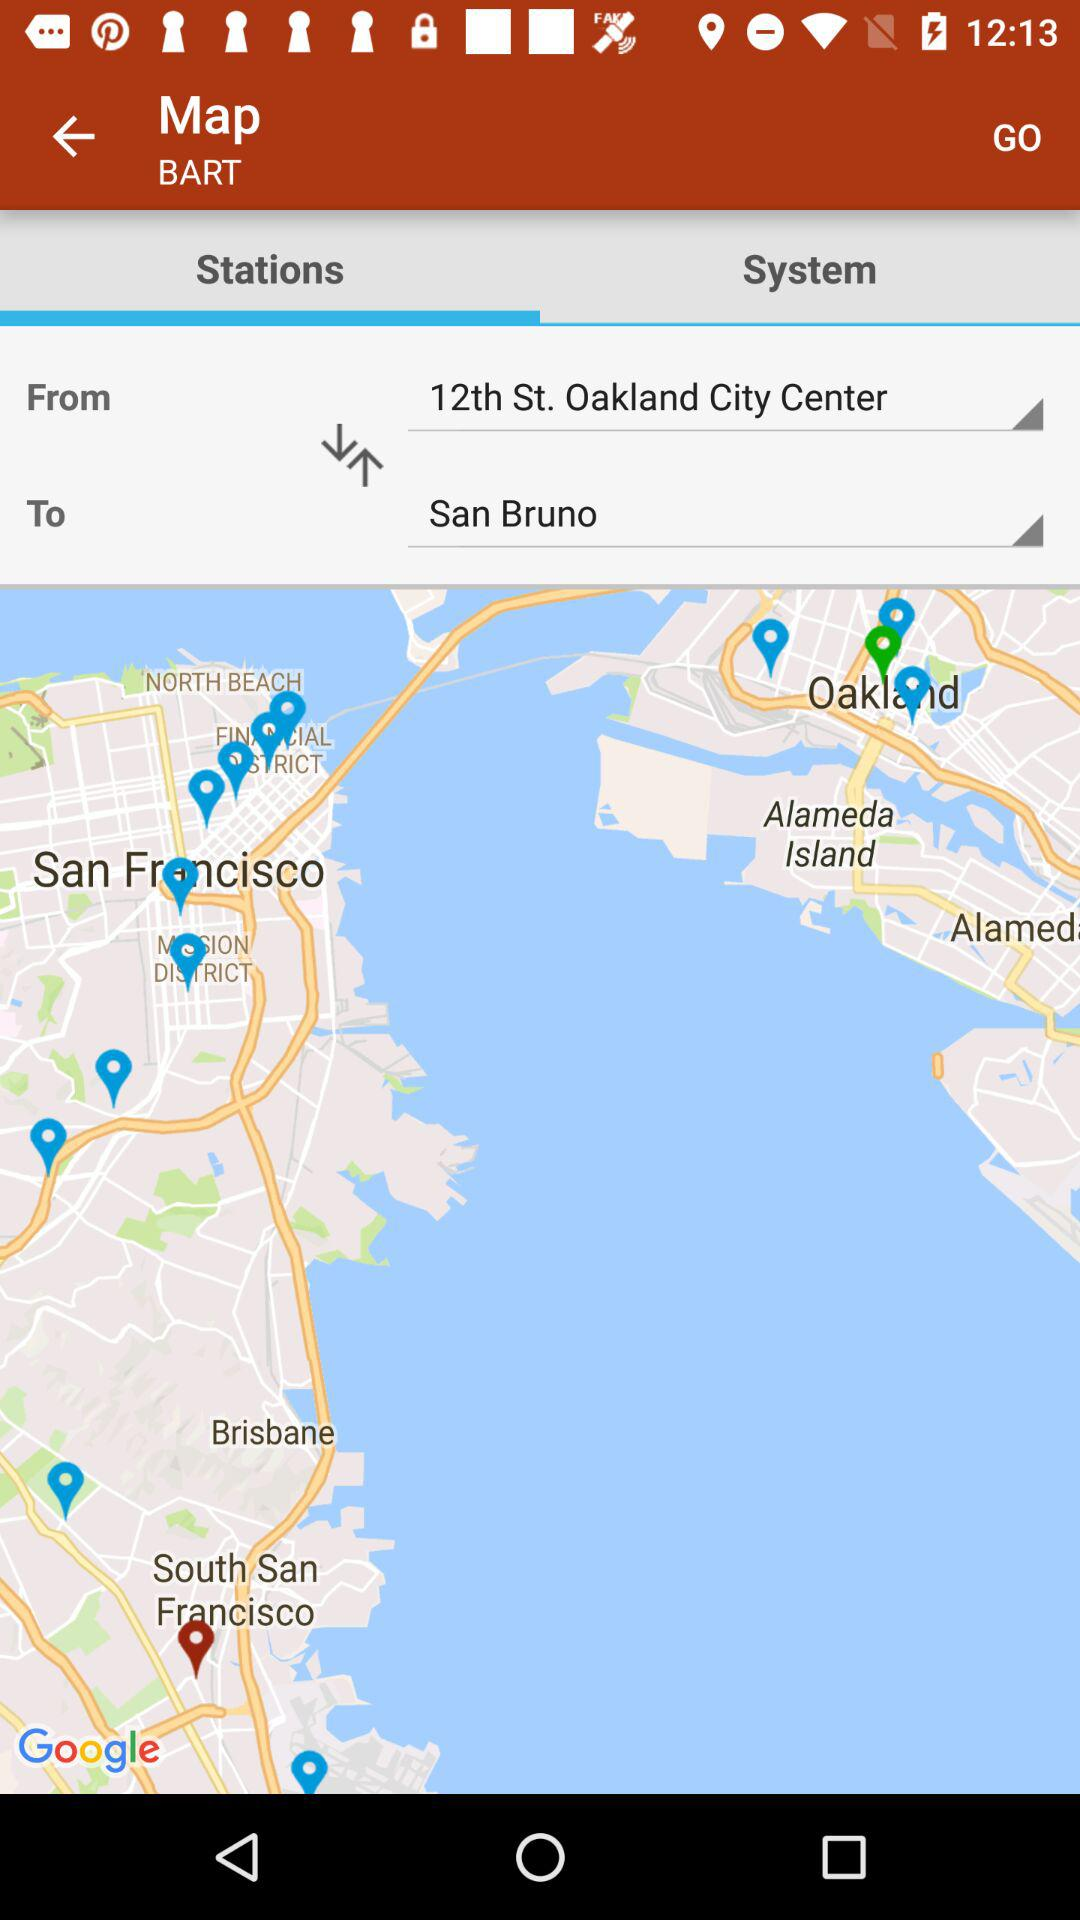What is the start location? The start location is 12th Street in Oakland City Center. 